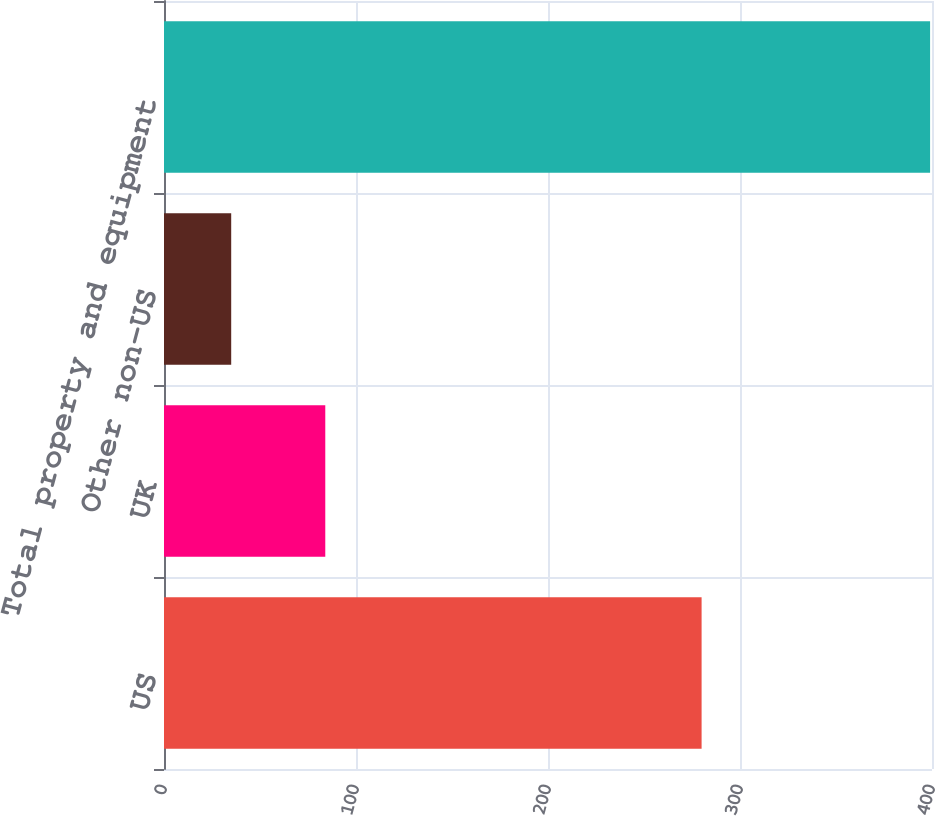Convert chart to OTSL. <chart><loc_0><loc_0><loc_500><loc_500><bar_chart><fcel>US<fcel>UK<fcel>Other non-US<fcel>Total property and equipment<nl><fcel>280<fcel>84<fcel>35<fcel>399<nl></chart> 